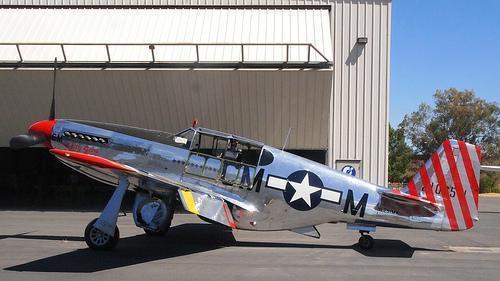How many planes are there?
Give a very brief answer. 1. 